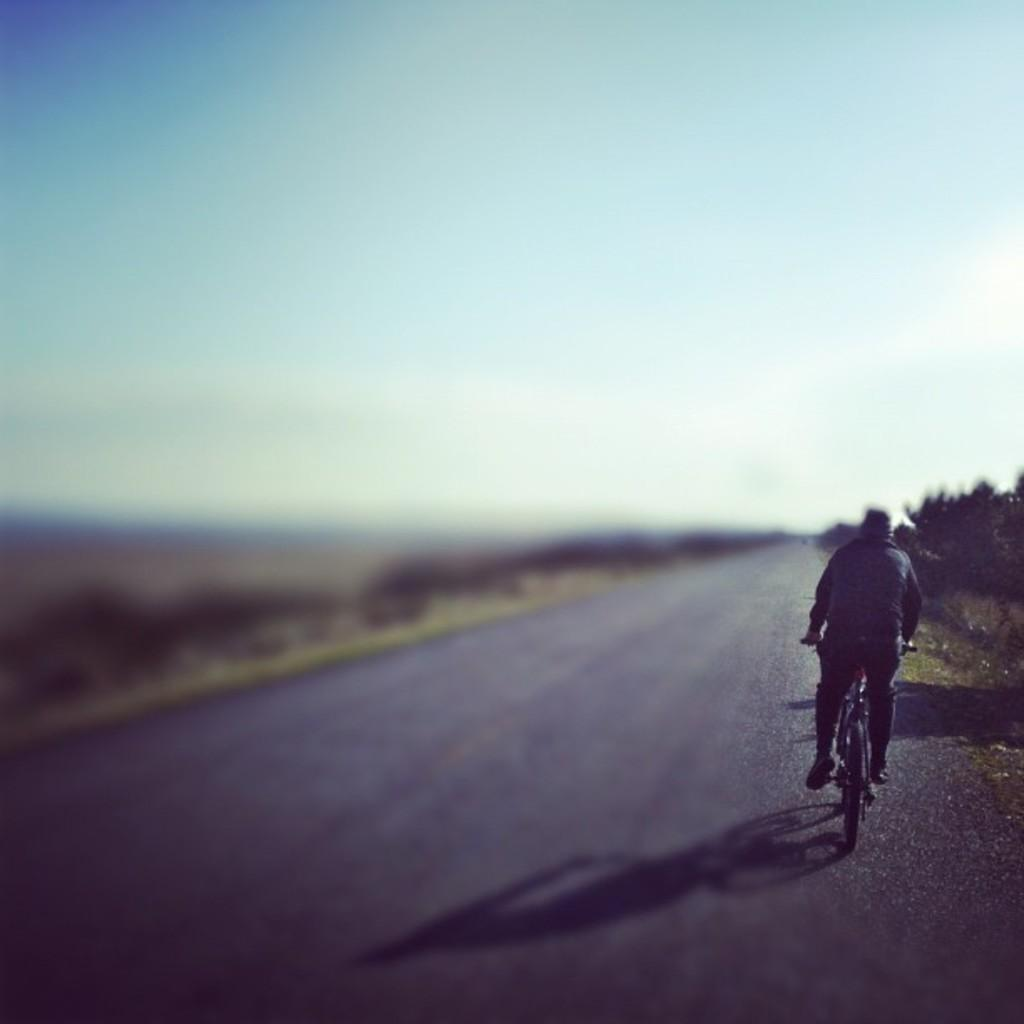What is the person in the image doing? The person is sitting on a bicycle in the image. Where is the person riding the bicycle? The person is riding the bicycle on a road. What can be seen on the right side of the image? There are trees on the right side of the image. What is visible at the top of the image? The sky is visible at the top of the image. How would you describe the left side of the image? The left side of the image is blurry. What is the value of the ink used to draw the bicycle in the image? There is no ink used to draw the bicycle in the image, as it is a photograph. How does the person kick the bicycle while riding it in the image? The person is not kicking the bicycle in the image; they are simply riding it. 